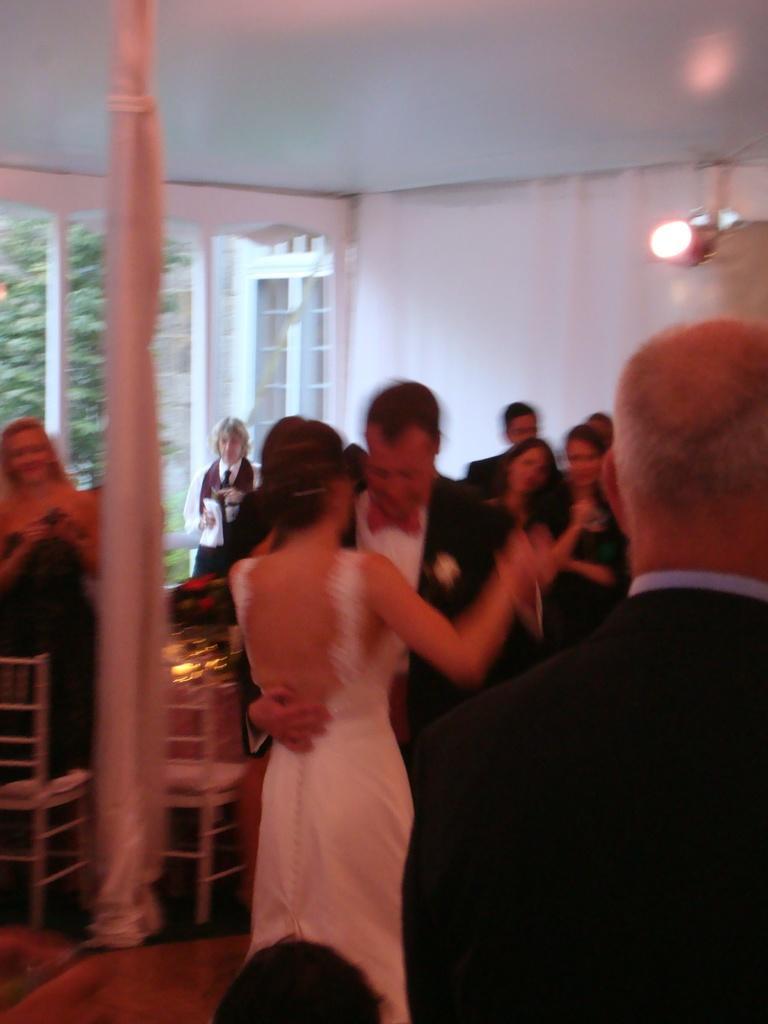Please provide a concise description of this image. In this picture there is a man and woman were dancing, beside them we can see the audience watching them. On the left there are two chairs near to the table. In the top left we can see the doors and trees. In the top right corner there is a light. 